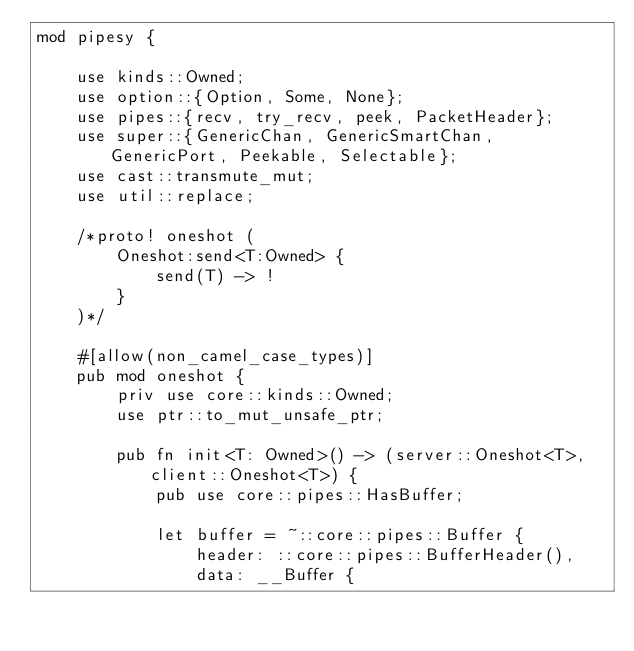Convert code to text. <code><loc_0><loc_0><loc_500><loc_500><_Rust_>mod pipesy {

    use kinds::Owned;
    use option::{Option, Some, None};
    use pipes::{recv, try_recv, peek, PacketHeader};
    use super::{GenericChan, GenericSmartChan, GenericPort, Peekable, Selectable};
    use cast::transmute_mut;
    use util::replace;

    /*proto! oneshot (
        Oneshot:send<T:Owned> {
            send(T) -> !
        }
    )*/

    #[allow(non_camel_case_types)]
    pub mod oneshot {
        priv use core::kinds::Owned;
        use ptr::to_mut_unsafe_ptr;

        pub fn init<T: Owned>() -> (server::Oneshot<T>, client::Oneshot<T>) {
            pub use core::pipes::HasBuffer;

            let buffer = ~::core::pipes::Buffer {
                header: ::core::pipes::BufferHeader(),
                data: __Buffer {</code> 